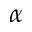<formula> <loc_0><loc_0><loc_500><loc_500>\alpha</formula> 